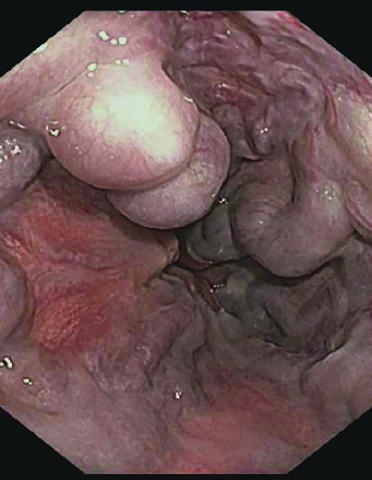what is striking?
Answer the question using a single word or phrase. The angiogram 